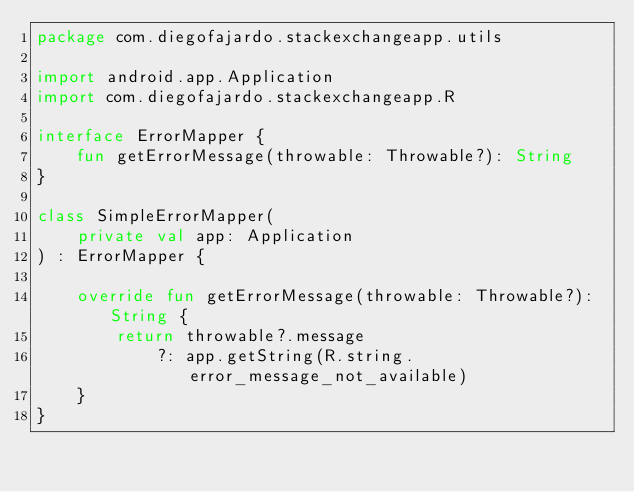Convert code to text. <code><loc_0><loc_0><loc_500><loc_500><_Kotlin_>package com.diegofajardo.stackexchangeapp.utils

import android.app.Application
import com.diegofajardo.stackexchangeapp.R

interface ErrorMapper {
    fun getErrorMessage(throwable: Throwable?): String
}

class SimpleErrorMapper(
    private val app: Application
) : ErrorMapper {

    override fun getErrorMessage(throwable: Throwable?): String {
        return throwable?.message
            ?: app.getString(R.string.error_message_not_available)
    }
}</code> 